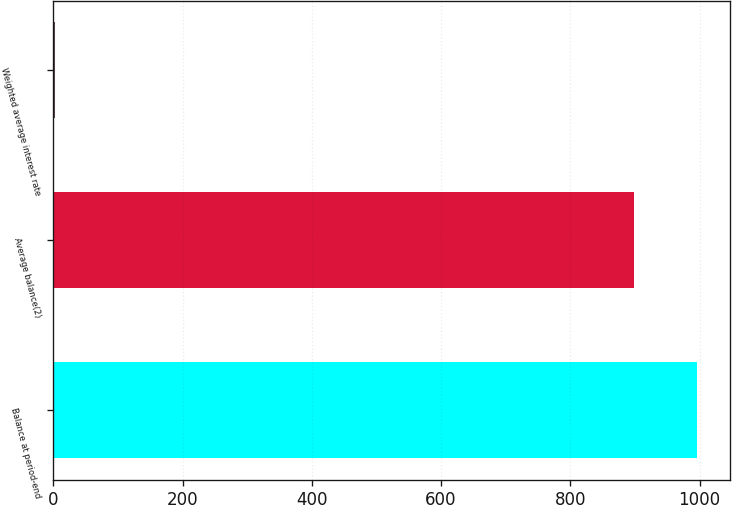<chart> <loc_0><loc_0><loc_500><loc_500><bar_chart><fcel>Balance at period-end<fcel>Average balance(2)<fcel>Weighted average interest rate<nl><fcel>996.53<fcel>899<fcel>2.7<nl></chart> 